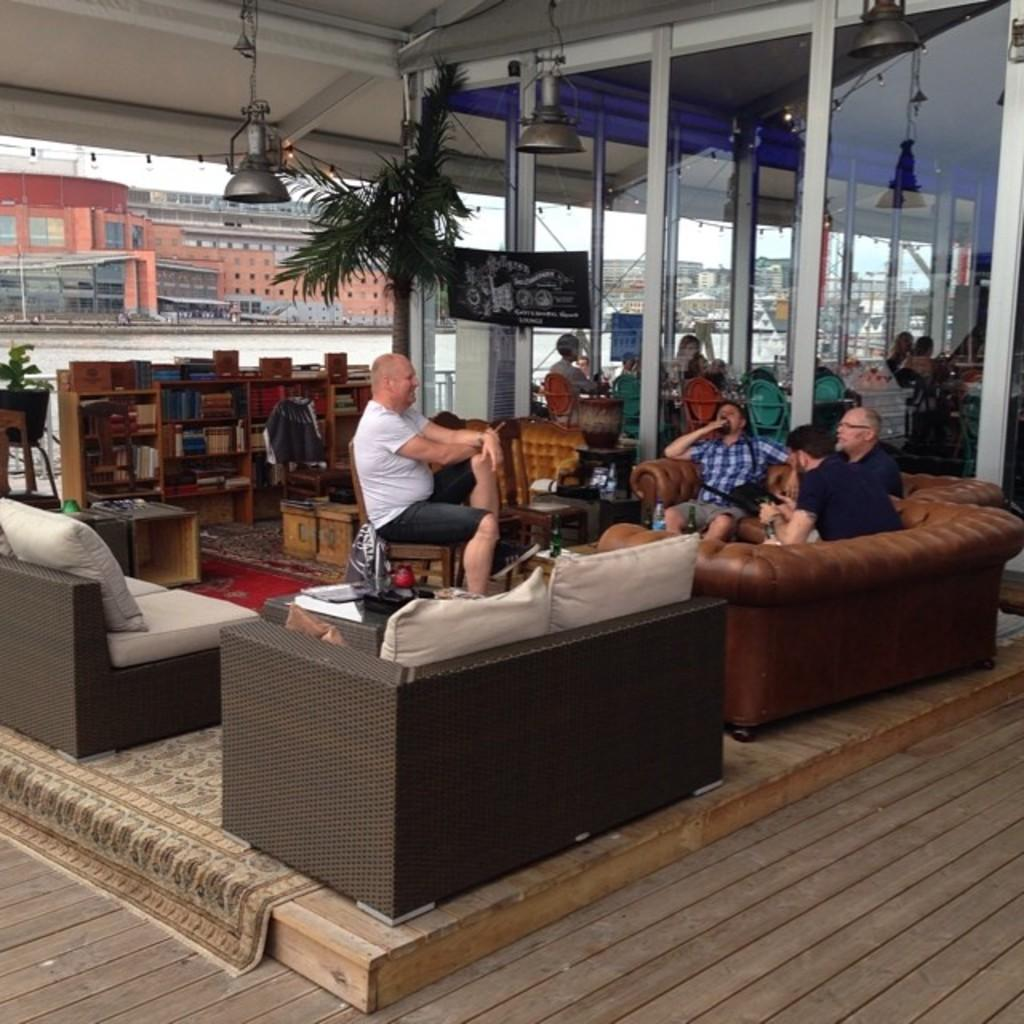How many men are sitting on the couch in the image? There are four men sitting on the couch in the image. What can be seen in the background of the image? In the background, there is a cupboard, books, a small plant, a building, a road, and a light visible at the top of the image. What is inside the cupboard in the image? There are books inside the cupboard in the image. What type of glue is being used to hold the cow in the image? There is no cow present in the image, and therefore no glue or any related activity can be observed. 